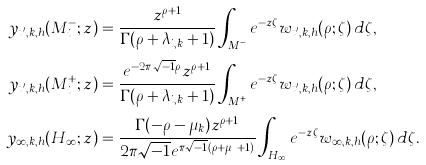<formula> <loc_0><loc_0><loc_500><loc_500>y _ { t ^ { \prime } _ { i } , k , h } ( M _ { i } ^ { - } ; z ) & = \frac { z ^ { \rho + 1 } } { \Gamma ( \rho + \lambda _ { i , k } + 1 ) } \int _ { M _ { i } ^ { - } } e ^ { - z \zeta } w _ { t ^ { \prime } _ { i } , k , h } ( \rho ; \zeta ) \, d \zeta , \\ y _ { t ^ { \prime } _ { i } , k , h } ( M _ { i } ^ { + } ; z ) & = \frac { e ^ { - 2 \pi \sqrt { - 1 } \rho } z ^ { \rho + 1 } } { \Gamma ( \rho + \lambda _ { i , k } + 1 ) } \int _ { M _ { i } ^ { + } } e ^ { - z \zeta } w _ { t ^ { \prime } _ { i } , k , h } ( \rho ; \zeta ) \, d \zeta , \\ y _ { \infty , k , h } ( H _ { \infty } ; z ) & = \frac { \Gamma ( - \rho - \mu _ { k } ) z ^ { \rho + 1 } } { 2 \pi \sqrt { - 1 } e ^ { \pi \sqrt { - 1 } ( \rho + \mu _ { k } + 1 ) } } \int _ { H _ { \infty } } e ^ { - z \zeta } w _ { \infty , k , h } ( \rho ; \zeta ) \, d \zeta .</formula> 